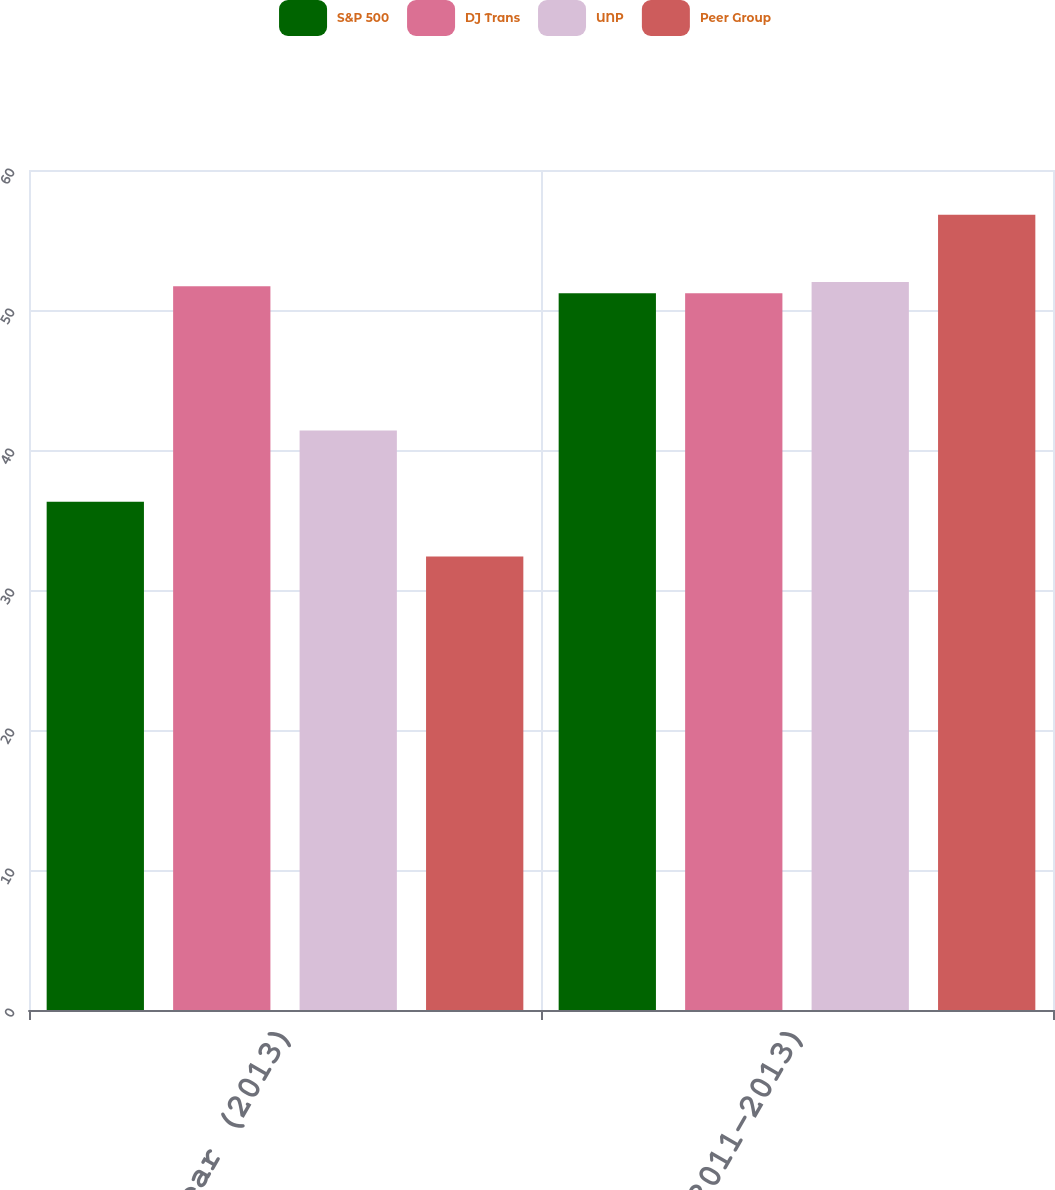Convert chart. <chart><loc_0><loc_0><loc_500><loc_500><stacked_bar_chart><ecel><fcel>1 Year (2013)<fcel>3 Year (2011-2013)<nl><fcel>S&P 500<fcel>36.3<fcel>51.2<nl><fcel>DJ Trans<fcel>51.7<fcel>51.2<nl><fcel>UNP<fcel>41.4<fcel>52<nl><fcel>Peer Group<fcel>32.4<fcel>56.8<nl></chart> 